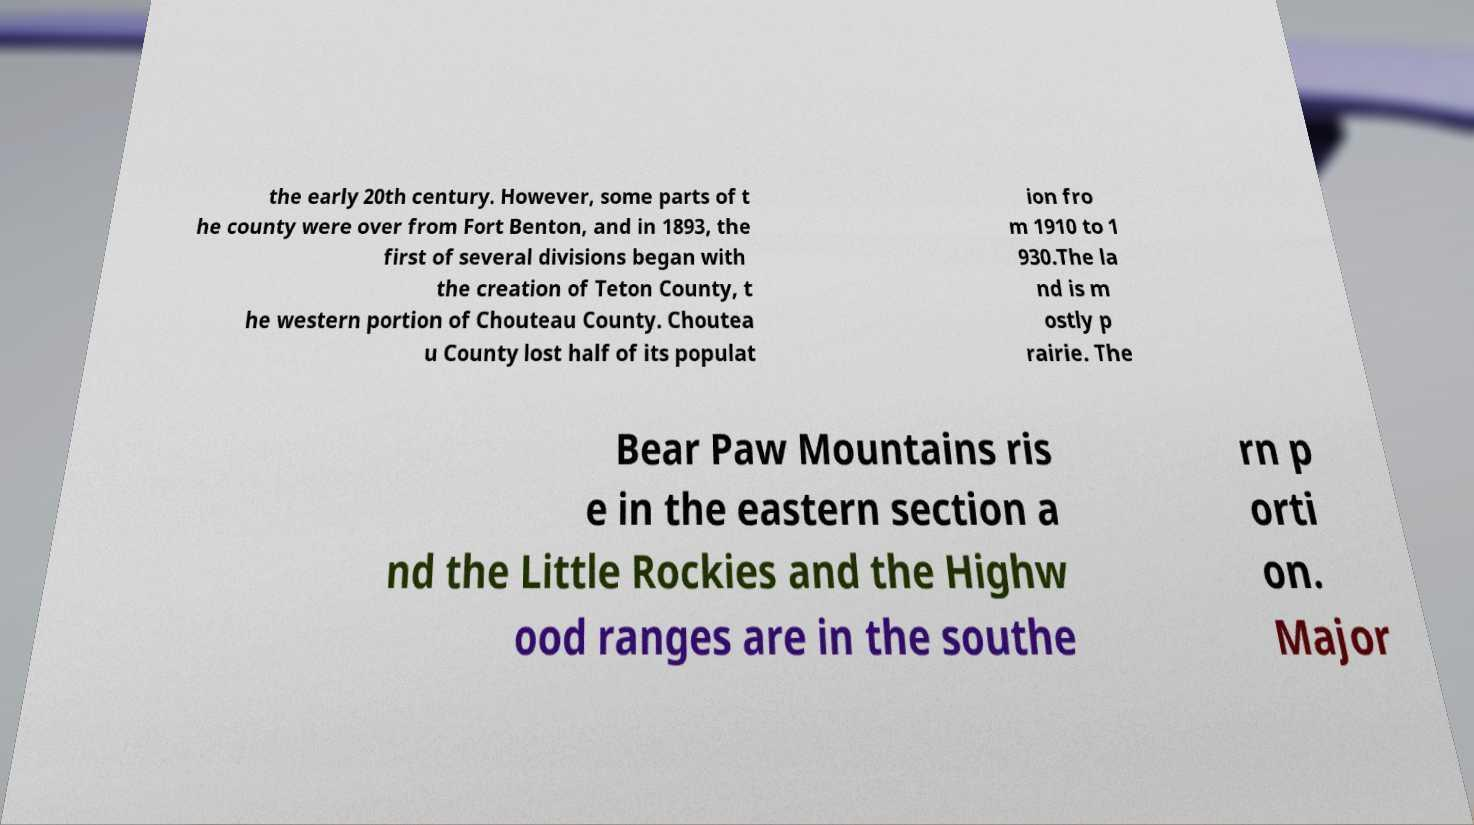Please identify and transcribe the text found in this image. the early 20th century. However, some parts of t he county were over from Fort Benton, and in 1893, the first of several divisions began with the creation of Teton County, t he western portion of Chouteau County. Choutea u County lost half of its populat ion fro m 1910 to 1 930.The la nd is m ostly p rairie. The Bear Paw Mountains ris e in the eastern section a nd the Little Rockies and the Highw ood ranges are in the southe rn p orti on. Major 